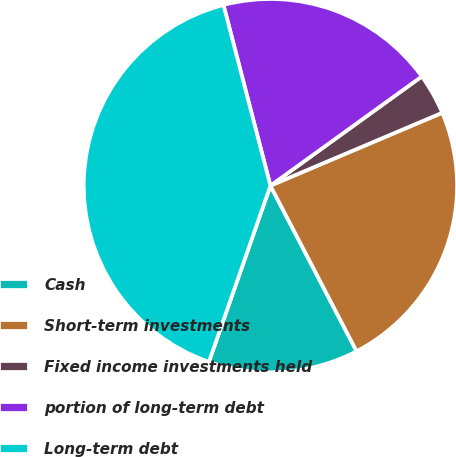Convert chart. <chart><loc_0><loc_0><loc_500><loc_500><pie_chart><fcel>Cash<fcel>Short-term investments<fcel>Fixed income investments held<fcel>portion of long-term debt<fcel>Long-term debt<nl><fcel>12.98%<fcel>23.75%<fcel>3.56%<fcel>19.1%<fcel>40.61%<nl></chart> 